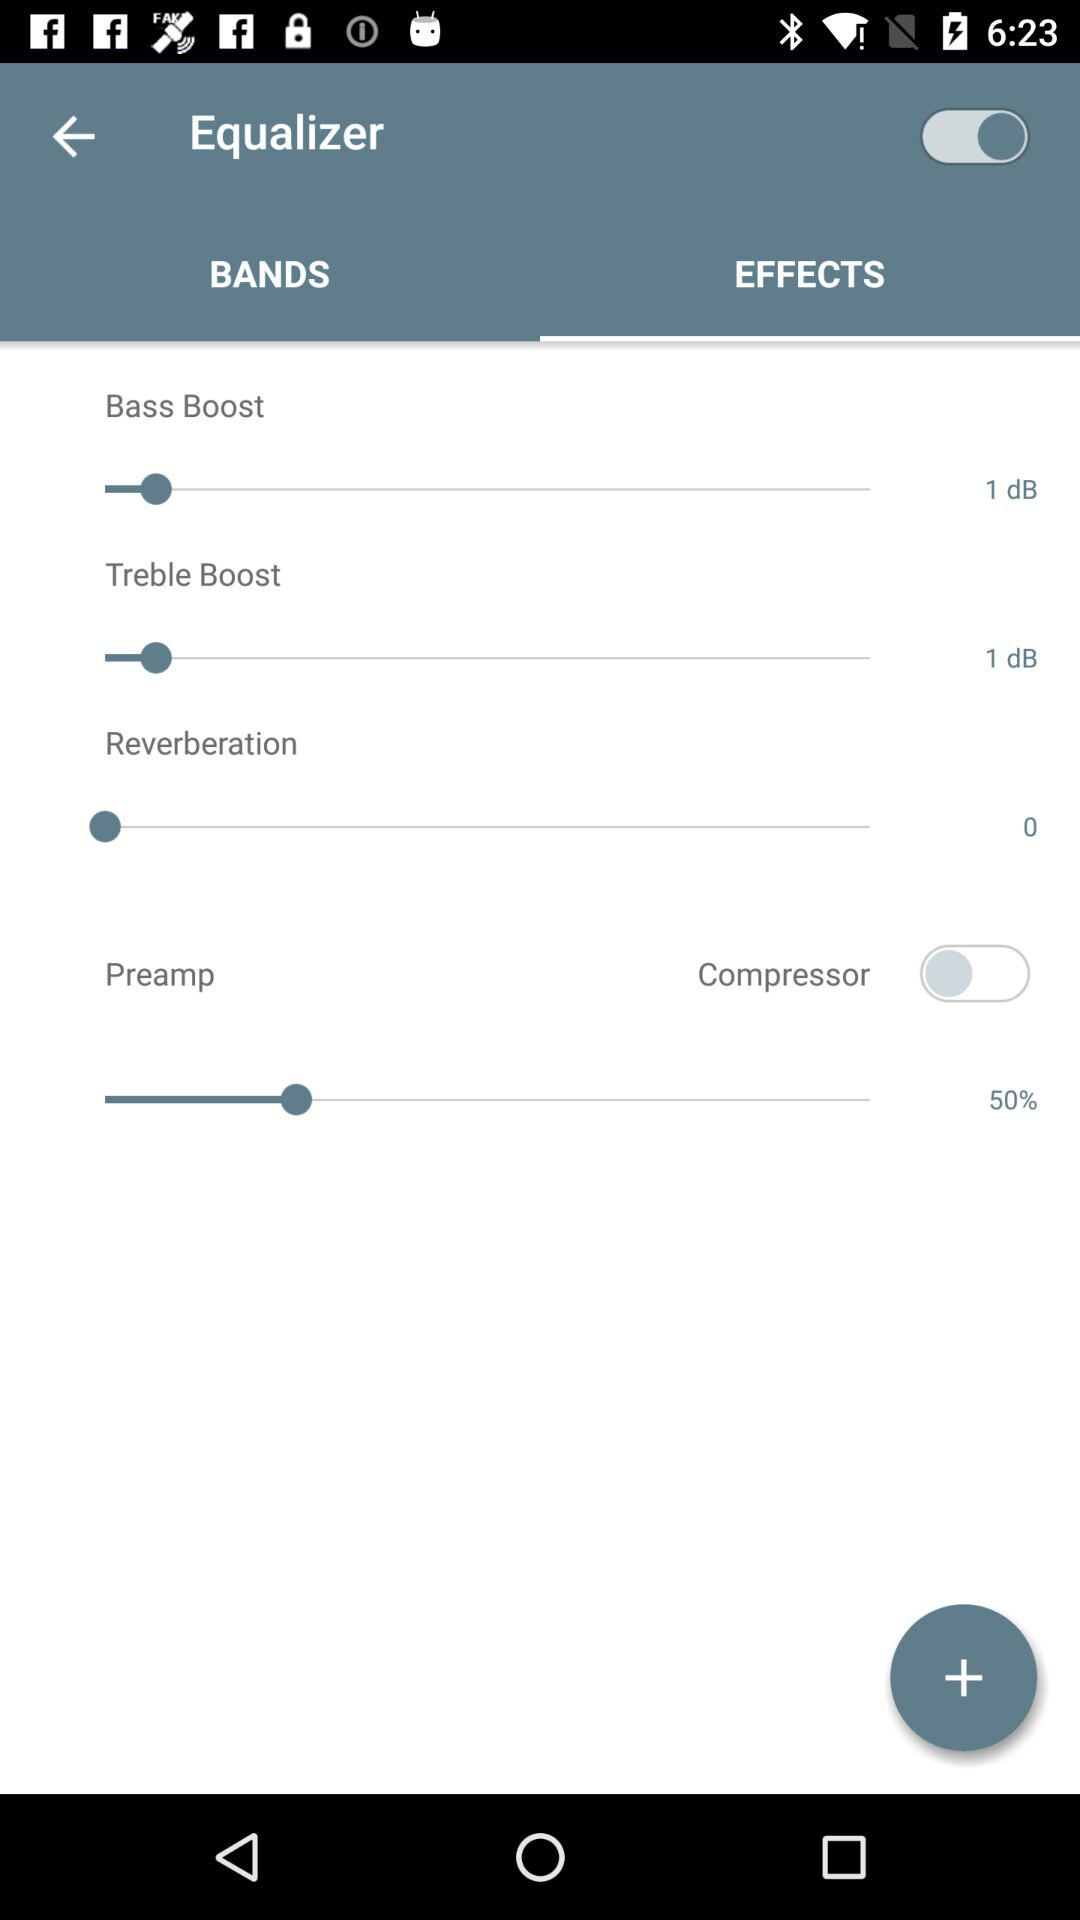How many effects are there in total?
Answer the question using a single word or phrase. 4 